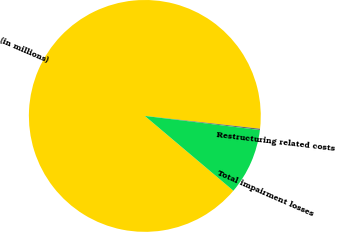Convert chart to OTSL. <chart><loc_0><loc_0><loc_500><loc_500><pie_chart><fcel>(in millions)<fcel>Restructuring related costs<fcel>Total impairment losses<nl><fcel>90.6%<fcel>0.18%<fcel>9.22%<nl></chart> 